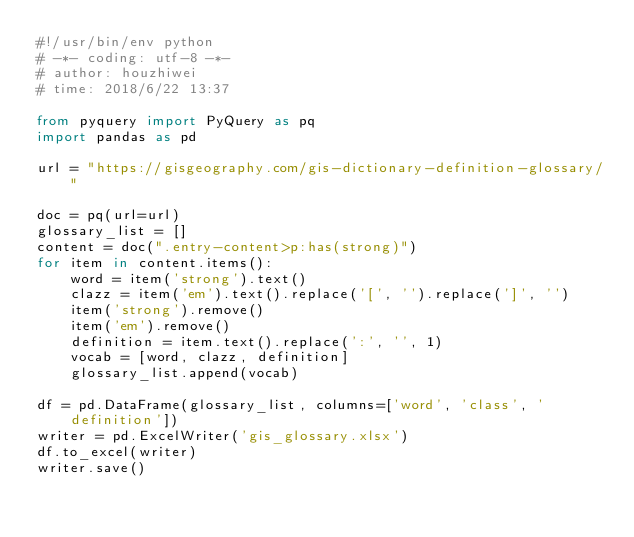<code> <loc_0><loc_0><loc_500><loc_500><_Python_>#!/usr/bin/env python
# -*- coding: utf-8 -*-
# author: houzhiwei
# time: 2018/6/22 13:37

from pyquery import PyQuery as pq
import pandas as pd

url = "https://gisgeography.com/gis-dictionary-definition-glossary/"

doc = pq(url=url)
glossary_list = []
content = doc(".entry-content>p:has(strong)")
for item in content.items():
	word = item('strong').text()
	clazz = item('em').text().replace('[', '').replace(']', '')
	item('strong').remove()
	item('em').remove()
	definition = item.text().replace(':', '', 1)
	vocab = [word, clazz, definition]
	glossary_list.append(vocab)

df = pd.DataFrame(glossary_list, columns=['word', 'class', 'definition'])
writer = pd.ExcelWriter('gis_glossary.xlsx')
df.to_excel(writer)
writer.save()
</code> 